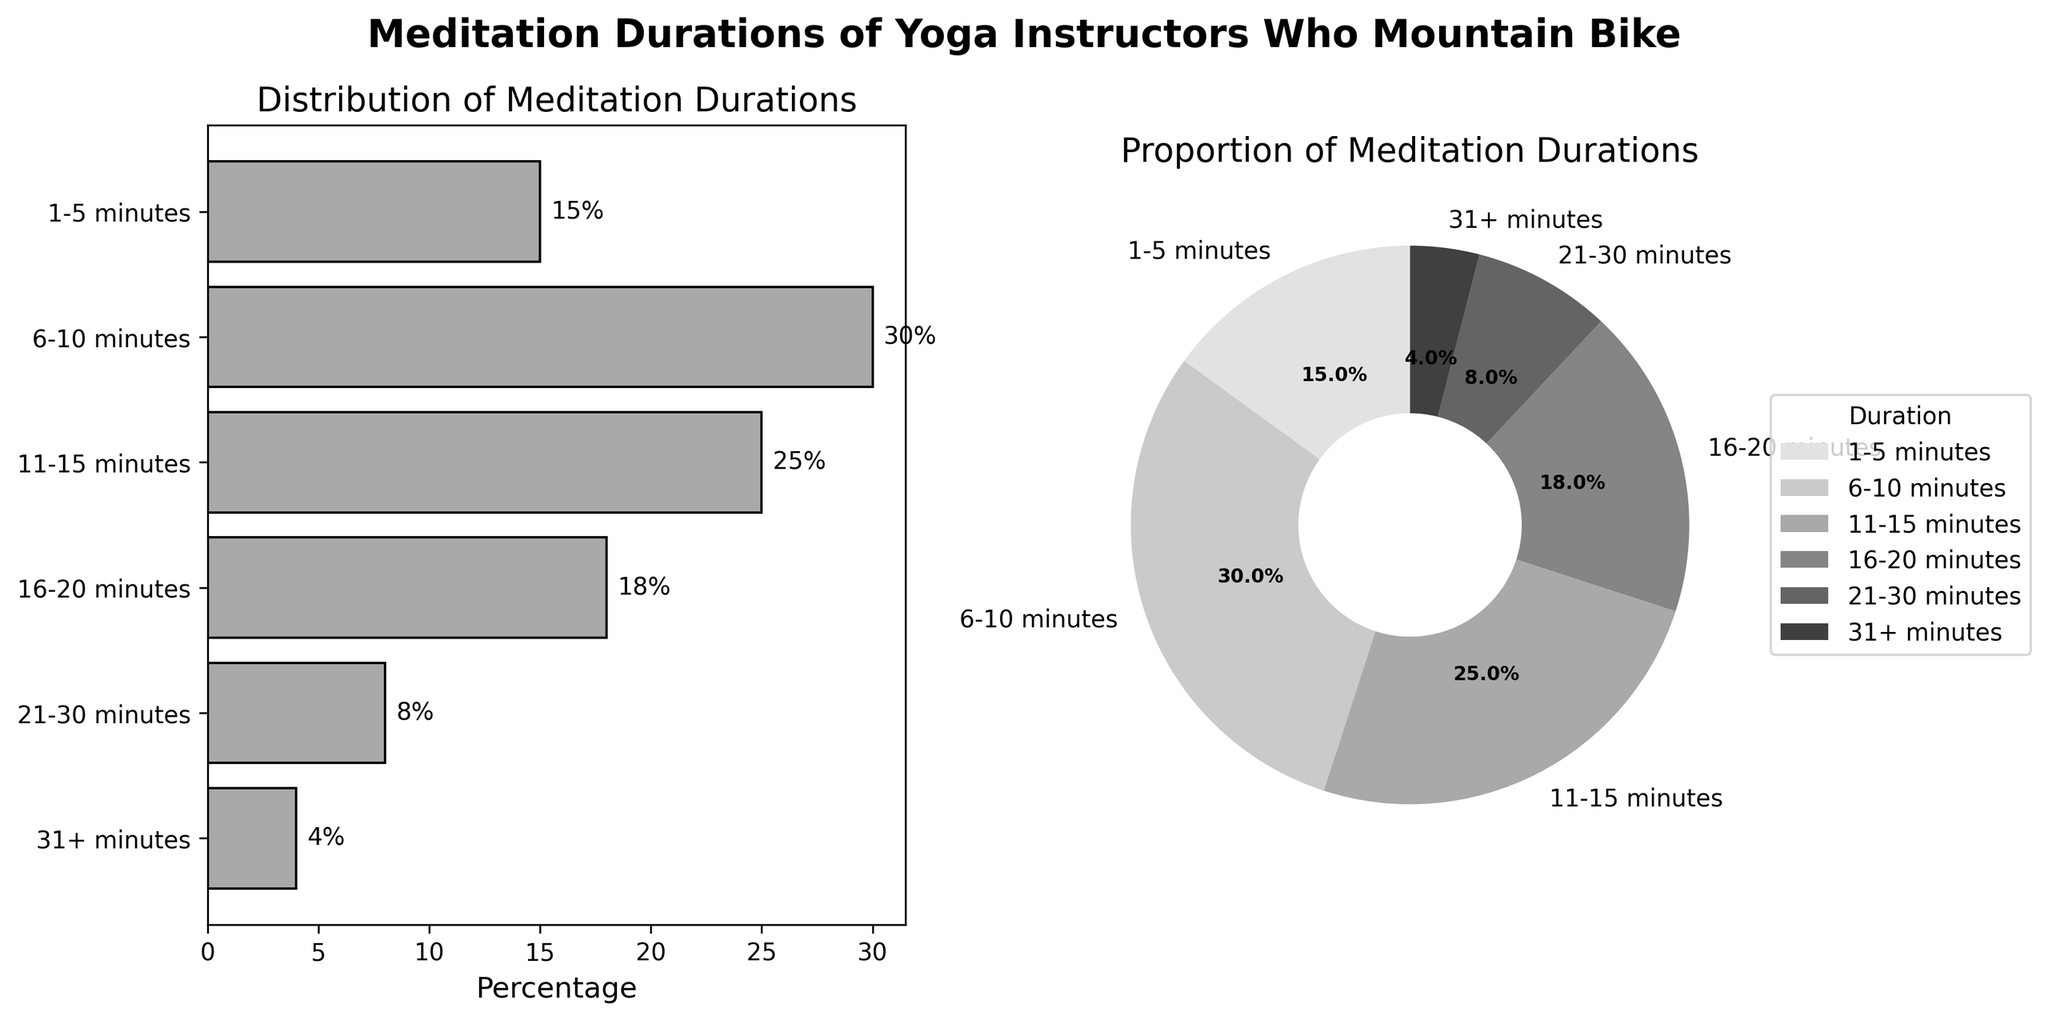How many categories of meditation durations are shown in the bar plot? By observing the y-axis of the bar plot, we can count the number of categories shown. Each bar represents a different category.
Answer: 6 Which meditation duration has the highest percentage? By examining the lengths of the bars in the bar plot and the segments in the pie chart, we can identify which category has the longest bar or the largest pie segment. The 6-10 minutes duration stands out as the highest.
Answer: 6-10 minutes What is the total percentage of meditation durations that are less than or equal to 15 minutes? We need to sum the percentages of the categories that fall under 1-5 minutes, 6-10 minutes, and 11-15 minutes. Their respective percentages are 15%, 30%, and 25%. The total is 15 + 30 + 25.
Answer: 70% What proportion of yoga instructors meditate for more than 20 minutes? By looking at the categories above 20 minutes in duration (21-30 minutes and 31+ minutes), we add their percentages (8% and 4%). The combined proportion is 8 + 4.
Answer: 12% Between the categories '16-20 minutes' and '21-30 minutes', which one has a higher percentage and by how much? By comparing the two categories in both the bar plot and pie chart, we see '16-20 minutes' has 18% and '21-30 minutes' has 8%. Subtracting 8 from 18 gives the difference.
Answer: 16-20 minutes by 10% What is the average percentage of the meditation durations? To find the average duration percentage, sum all percentages and divide by the number of categories. The total is 15 + 30 + 25 + 18 + 8 + 4 which equals 100. There are 6 categories, so 100/6.
Answer: ~16.67% Which category of meditation duration has the smallest pie segment in the pie chart? By inspecting the smallest segment in the pie chart, we can determine it belongs to the '31+ minutes' category.
Answer: 31+ minutes How does the distribution shape in the pie chart compare to the bar plot? Both plots show the same data but in different formats. The bar plot shows it horizontally with bars of different lengths representing percentages, while the pie chart shows it circularly with segments of different sizes. Both have the highest segment for the 6-10 minutes category and the smallest for the 31+ minutes category.
Answer: Both are the same in distribution conclusion 